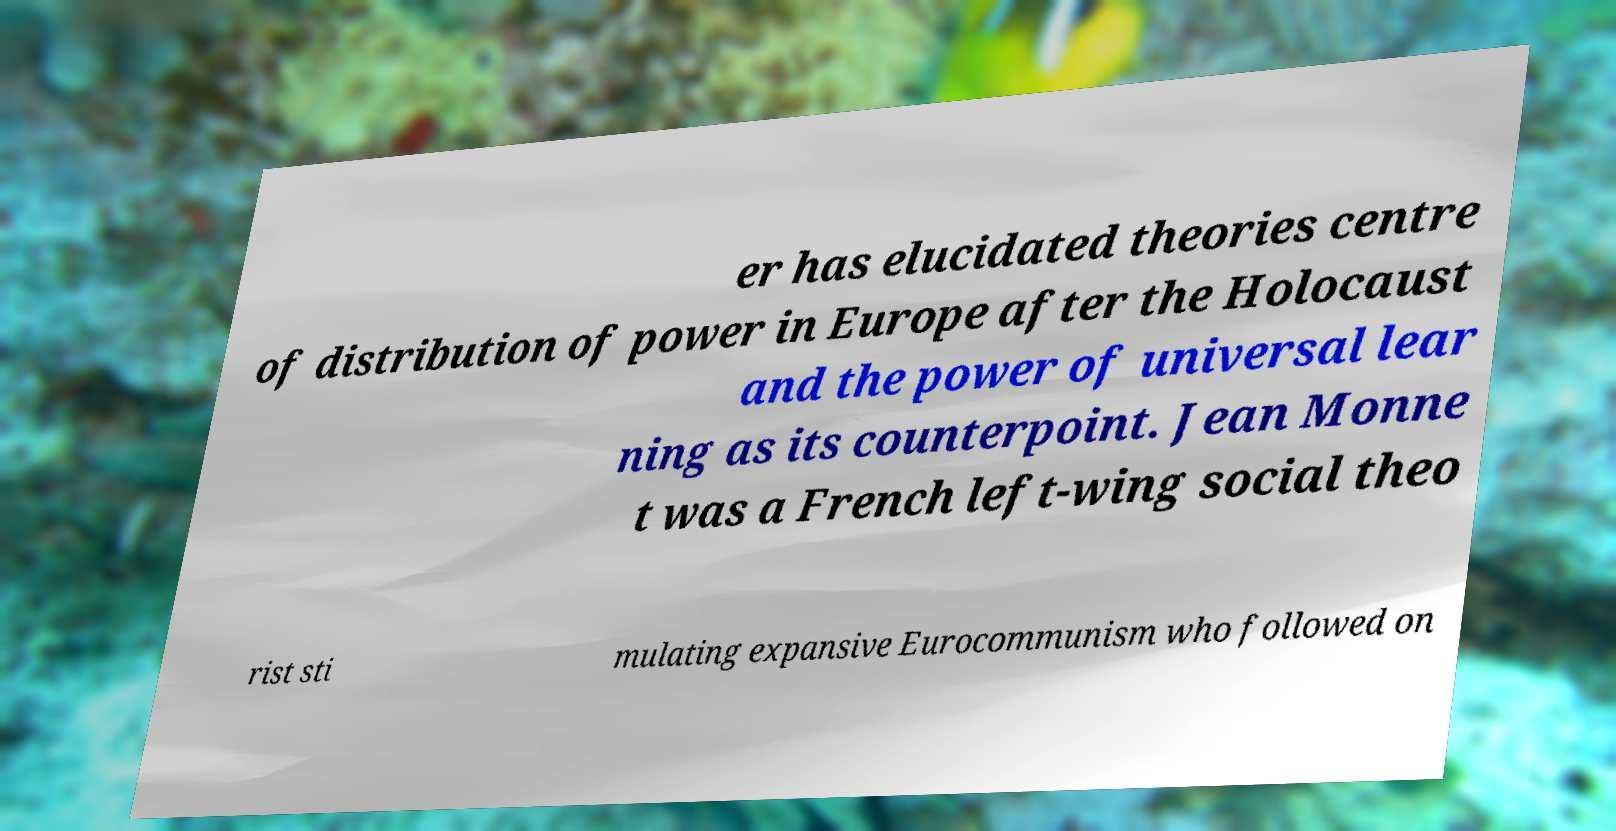Please identify and transcribe the text found in this image. er has elucidated theories centre of distribution of power in Europe after the Holocaust and the power of universal lear ning as its counterpoint. Jean Monne t was a French left-wing social theo rist sti mulating expansive Eurocommunism who followed on 